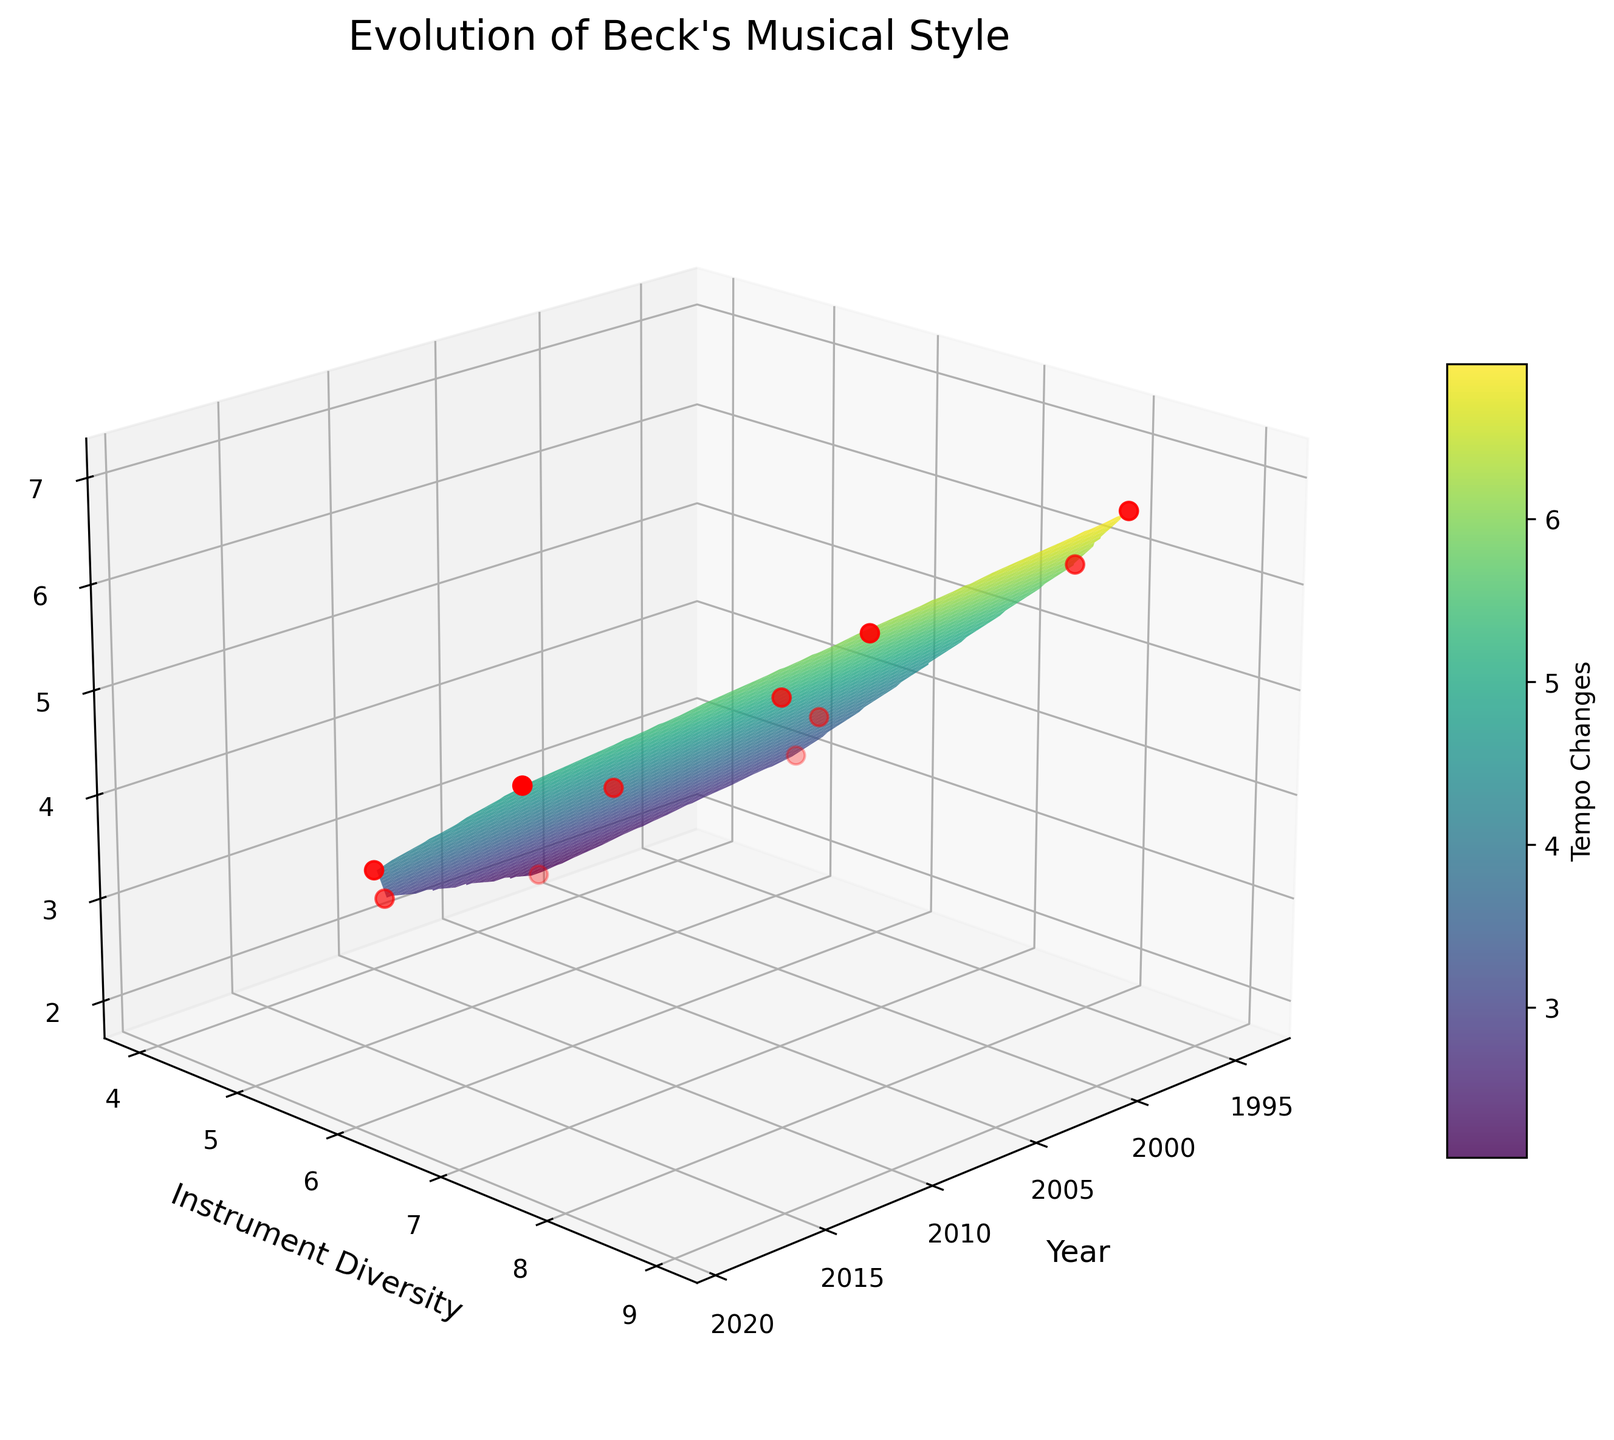What is the title of the figure? The title of the figure is shown at the top and summarizes the main subject of the plot.
Answer: Evolution of Beck's Musical Style What do the axes represent? The labels on the axes indicate what each axis measures. From the plot, you can see: The x-axis represents the year of album release, the y-axis measures instrument diversity, and the z-axis measures tempo changes.
Answer: Year, Instrument Diversity, Tempo Changes Which album has the highest values of both instrument diversity and tempo changes? By examining the peaks in the plot and cross-referencing with the scatter points, you can find that ‘Midnite Vultures’ (1999) has the highest values for both instrument diversity and tempo changes.
Answer: Midnite Vultures How did the instrument diversity and tempo changes evolve from 'Sea Change' (2002) to 'Guero' (2005)? ‘Sea Change’ has lower values in both instrument diversity and tempo changes compared to ‘Guero’. By observing the surface and scatter data points, you can see a rise in both metrics from 2002 to 2005.
Answer: Both increased What is the general trend of instrument diversity over the years? By looking at the y-axis (Instrument Diversity) and following the surface plot from early to later years, you see some fluctuations but no strong increasing or decreasing trend. The diversity roughly oscillates around a mid-level value with occasional peaks and troughs.
Answer: Oscillates Does the album 'Mutations' (1998) have higher tempo changes than 'Hyperspace' (2019)? To determine this, locate the scatter points for both albums in the figure. Mutations (1998) has a tempo change value of 4 while Hyperspace (2019) also has the same tempo change value of 4, suggesting they are equal.
Answer: No, they are equal How does the tempo change in 'Odelay' (1996) compare to 'Morning Phase' (2014)? By comparing the scatter points in the plot, you’ll see that the tempo changes for 'Odelay' are significantly higher than for 'Morning Phase' as indicated by their positioning on the z-axis.
Answer: Higher Among the earliest albums in the data ('Mellow Gold', 1994), how does the instrument diversity compare with 'Sea Change' (2002)? Checking the scatter points on the plot, 'Mellow Gold' has an instrument diversity of 5, while 'Sea Change' has an instrument diversity of 4, showing that 'Mellow Gold' has slightly higher instrument diversity.
Answer: Higher Which color is predominantly used to represent higher tempo changes on the plot? By examining the color gradient of the surface plot, you can see that higher tempo changes correspond to the lighter (yellow-greenish) areas.
Answer: Yellow-greenish Is there a noticeable drop in instrument diversity for any album compared to its preceding release? Yes, by examining the surface and scatter points, 'Sea Change' (2002) shows a noticeable drop in instrument diversity compared to the preceding album 'Midnite Vultures' (1999).
Answer: Yes, in 'Sea Change' 